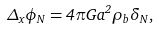Convert formula to latex. <formula><loc_0><loc_0><loc_500><loc_500>\Delta _ { x } \phi _ { N } = 4 \pi G a ^ { 2 } \rho _ { b } \delta _ { N } ,</formula> 